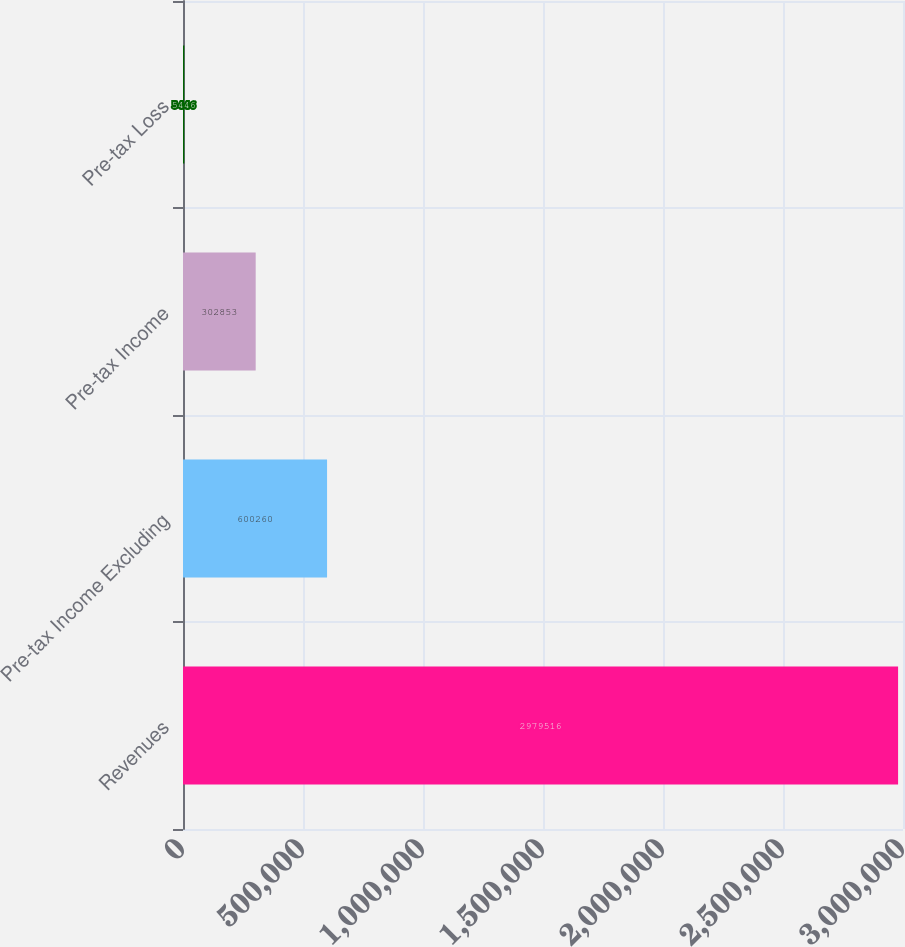Convert chart to OTSL. <chart><loc_0><loc_0><loc_500><loc_500><bar_chart><fcel>Revenues<fcel>Pre-tax Income Excluding<fcel>Pre-tax Income<fcel>Pre-tax Loss<nl><fcel>2.97952e+06<fcel>600260<fcel>302853<fcel>5446<nl></chart> 